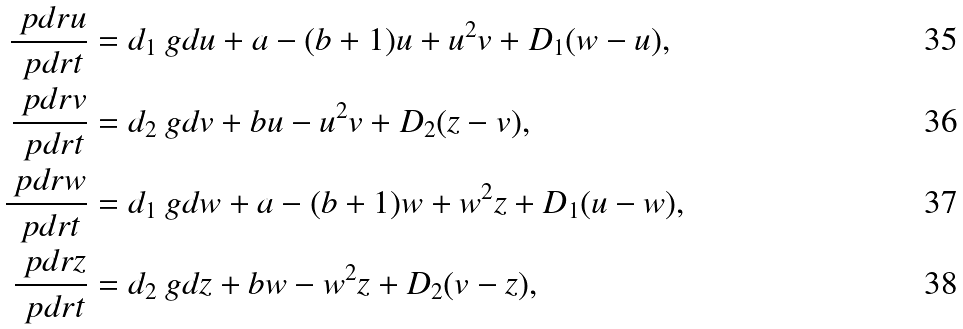Convert formula to latex. <formula><loc_0><loc_0><loc_500><loc_500>\frac { \ p d r u } { \ p d r t } & = d _ { 1 } \ g d u + a - ( b + 1 ) u + u ^ { 2 } v + D _ { 1 } ( w - u ) , \\ \frac { \ p d r v } { \ p d r t } & = d _ { 2 } \ g d v + b u - u ^ { 2 } v + D _ { 2 } ( z - v ) , \\ \frac { \ p d r w } { \ p d r t } & = d _ { 1 } \ g d w + a - ( b + 1 ) w + w ^ { 2 } z + D _ { 1 } ( u - w ) , \\ \frac { \ p d r z } { \ p d r t } & = d _ { 2 } \ g d z + b w - w ^ { 2 } z + D _ { 2 } ( v - z ) ,</formula> 